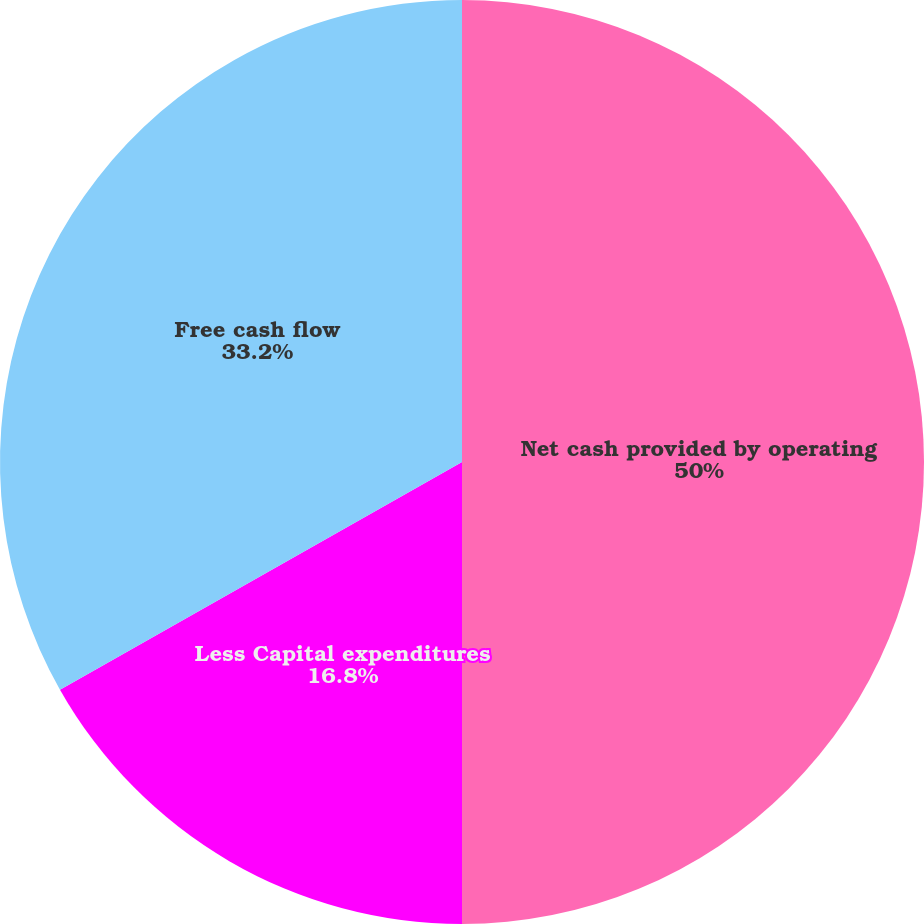<chart> <loc_0><loc_0><loc_500><loc_500><pie_chart><fcel>Net cash provided by operating<fcel>Less Capital expenditures<fcel>Free cash flow<nl><fcel>50.0%<fcel>16.8%<fcel>33.2%<nl></chart> 